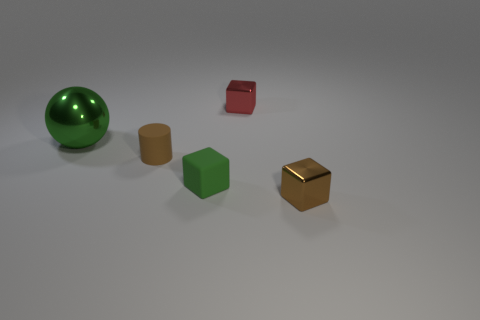Subtract all metal blocks. How many blocks are left? 1 Add 5 yellow rubber spheres. How many objects exist? 10 Subtract all cubes. How many objects are left? 2 Subtract all green blocks. How many blocks are left? 2 Subtract all yellow cylinders. Subtract all yellow cubes. How many cylinders are left? 1 Subtract all brown spheres. How many brown cubes are left? 1 Subtract all big green balls. Subtract all small red cubes. How many objects are left? 3 Add 4 small brown cubes. How many small brown cubes are left? 5 Add 2 brown cylinders. How many brown cylinders exist? 3 Subtract 0 blue cylinders. How many objects are left? 5 